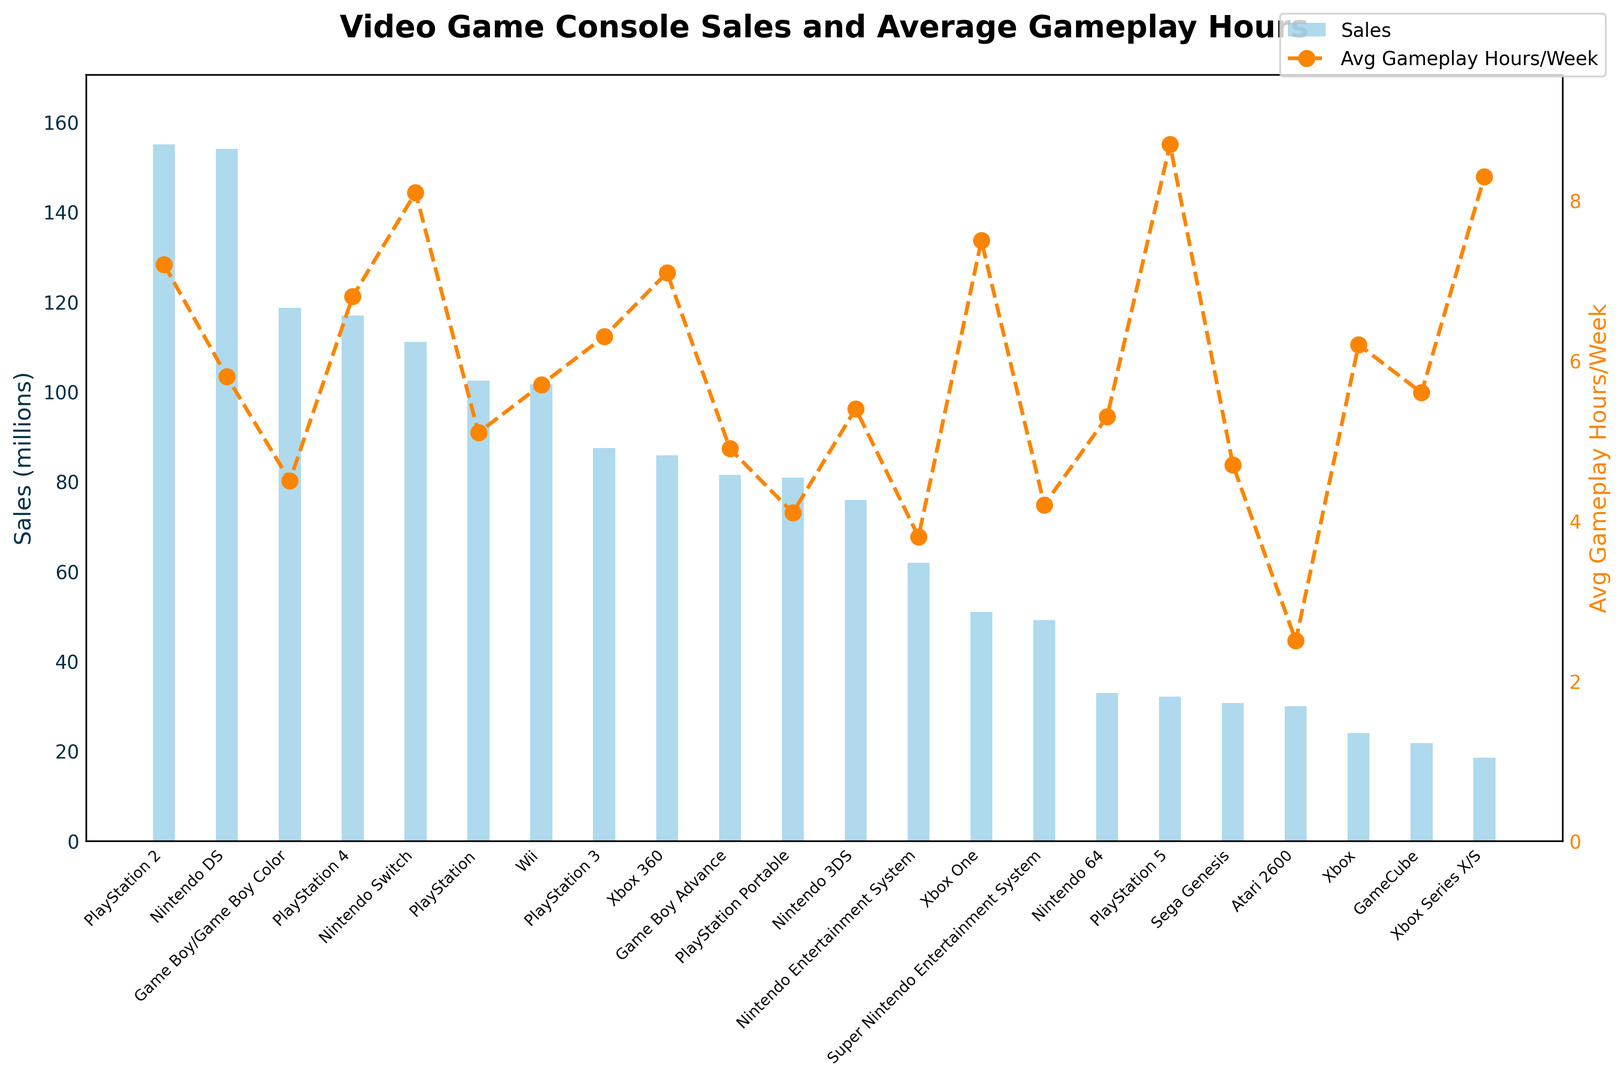What's the best-selling console? The best-selling console can be identified by the tallest blue bar in the bar chart. The tallest bar corresponds to the PlayStation 2.
Answer: PlayStation 2 Which console has the highest average gameplay hours per week? The console with the highest average gameplay hours per week can be identified by the peak of the orange line. The highest point on the orange line corresponds to the PlayStation 5, with 8.7 hours.
Answer: PlayStation 5 How much greater are the average gameplay hours per week for Xbox Series X/S compared to the PlayStation 4? To determine this, compare the orange markers for Xbox Series X/S and PlayStation 4. Xbox Series X/S has 8.3 hours while PlayStation 4 has 6.8 hours. Subtract the smaller value from the larger one. 8.3 - 6.8 = 1.5 hours.
Answer: 1.5 hours Which consoles have sales figures greater than 100 million? Look at the blue bars and identify those with heights above the 100 million mark on the y-axis. The consoles with sales figures over 100 million are PlayStation 2, Nintendo DS, Game Boy/Game Boy Color, PlayStation 4, Nintendo Switch, and PlayStation.
Answer: PlayStation 2, Nintendo DS, Game Boy/Game Boy Color, PlayStation 4, Nintendo Switch, PlayStation How do the sales of the Xbox 360 compare to the Nintendo Switch? Look at the heights of the blue bars for both consoles. Nintendo Switch has higher sales at approximately 111.08 million compared to 85.8 million for Xbox 360. Thus, Nintendo Switch sales are higher.
Answer: Nintendo Switch has higher sales What is the sum of sales for PlayStation 3 and Xbox One? Add the sales figures for PlayStation 3 and Xbox One. PlayStation 3 has 87.4 million, and Xbox One has 51 million. The sum is 87.4 + 51 = 138.4 million.
Answer: 138.4 million What is the trend in average gameplay hours for PlayStation consoles from PlayStation to PlayStation 5? By observing the orange line plot at the positions of all PlayStation consoles, we get: PlayStation (5.1), PlayStation 2 (7.2), PlayStation 3 (6.3), PlayStation 4 (6.8), and PlayStation 5 (8.7). The trend shows an initial increase, slight dips, and then another increase leading to the highest value at PlayStation 5.
Answer: Generally increasing trend Compare the sales of PlayStation 2 and Nintendo DS. Which has more sales and by how much? Identify the heights of the blue bars and the exact sales figures of PlayStation 2 and Nintendo DS. PlayStation 2 has 155 million, and Nintendo DS has 154.02 million. Subtract to find the difference: 155 - 154.02 = 0.98 million.
Answer: PlayStation 2 by 0.98 million What's the average gameplay hours per week for the top 3 best-selling consoles? The top 3 best-selling consoles are PlayStation 2, Nintendo DS, and Game Boy/Game Boy Color. Their hours are 7.2, 5.8, and 4.5 respectively. Add these values and divide by 3. (7.2 + 5.8 + 4.5) / 3 = 5.83
Answer: 5.83 Which console, between Atari 2600 and Xbox, has higher average gameplay hours per week and by how much? Compare the orange line points for Atari 2600 and Xbox. Atari 2600 has 2.5 hours while Xbox has 6.2 hours. Subtract the smaller value from the larger one, 6.2 - 2.5 = 3.7 hours.
Answer: Xbox by 3.7 hours 